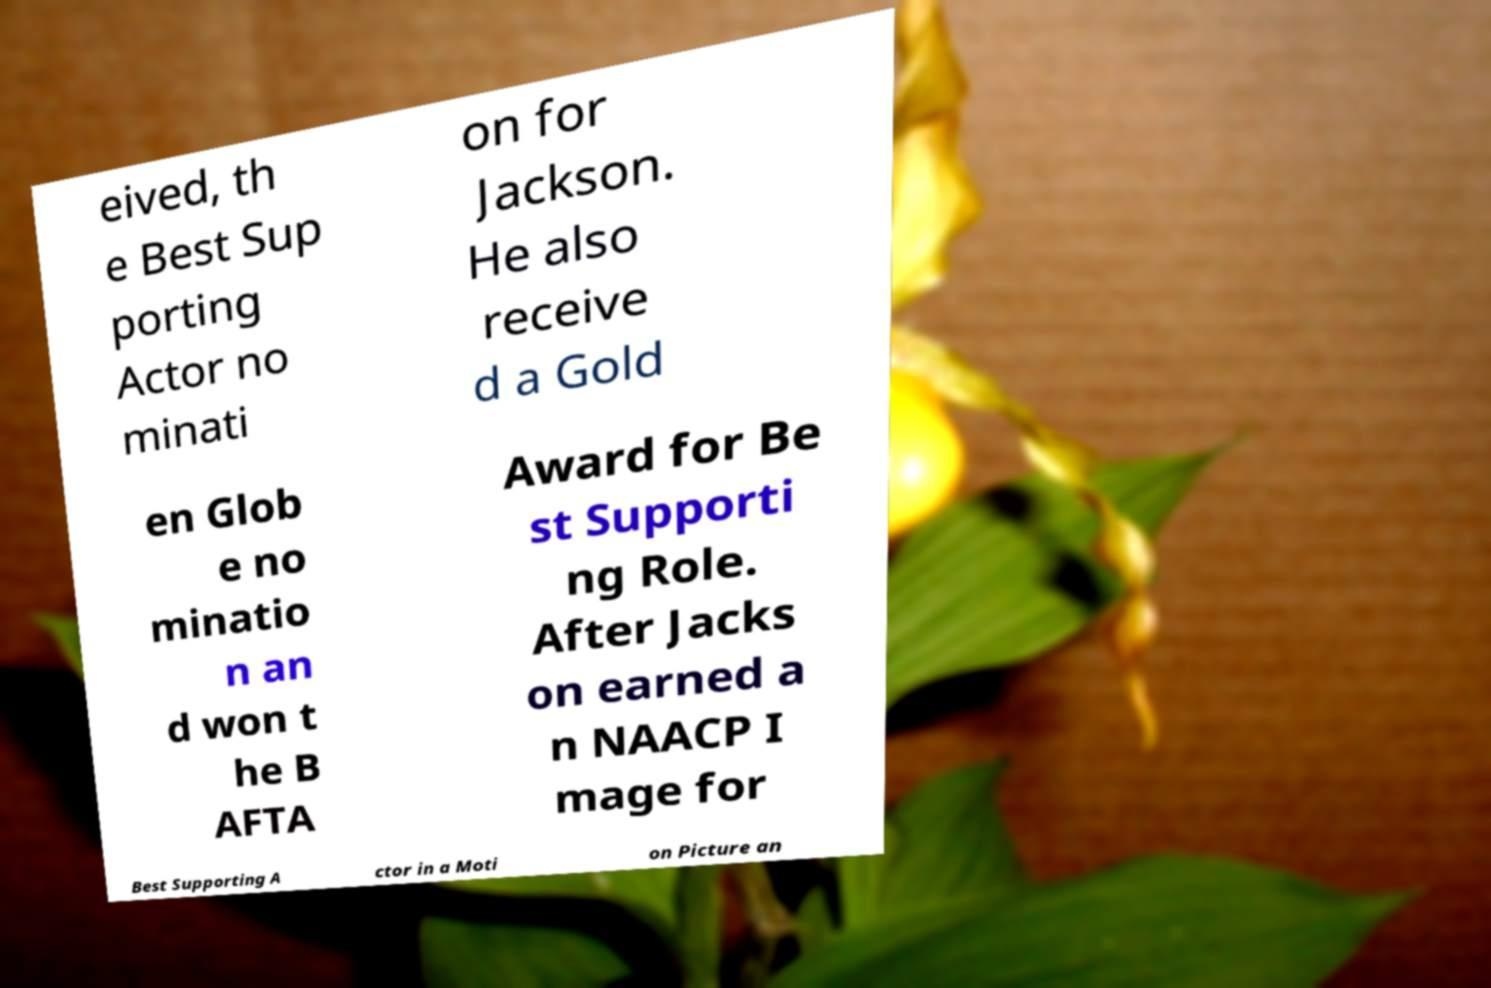Can you accurately transcribe the text from the provided image for me? eived, th e Best Sup porting Actor no minati on for Jackson. He also receive d a Gold en Glob e no minatio n an d won t he B AFTA Award for Be st Supporti ng Role. After Jacks on earned a n NAACP I mage for Best Supporting A ctor in a Moti on Picture an 